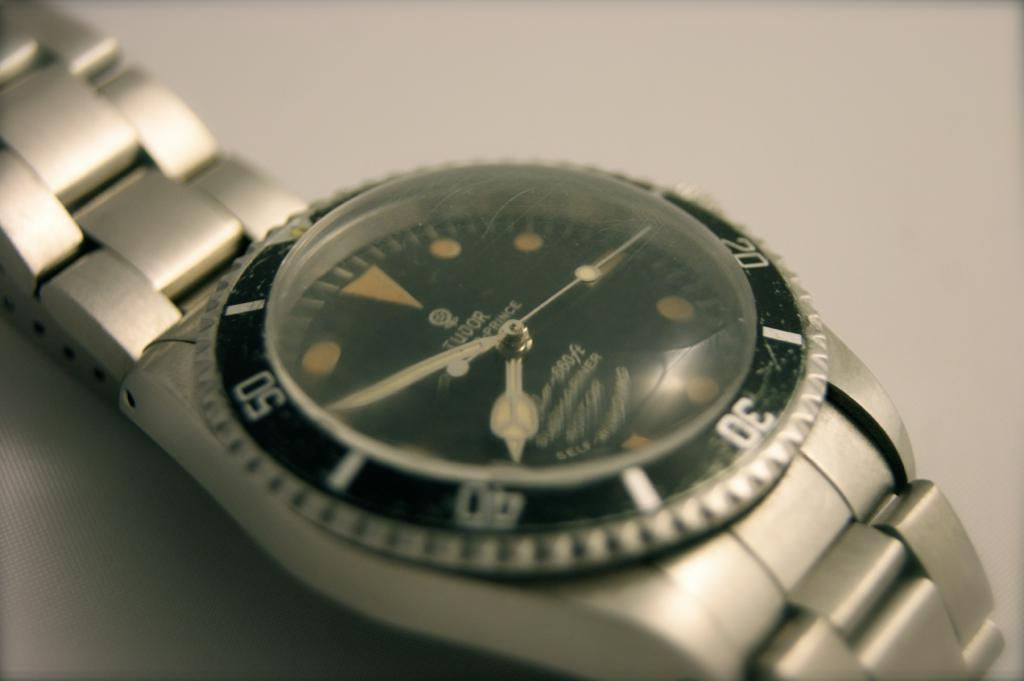<image>
Create a compact narrative representing the image presented. A silver and black Tudor watch laying flat. 